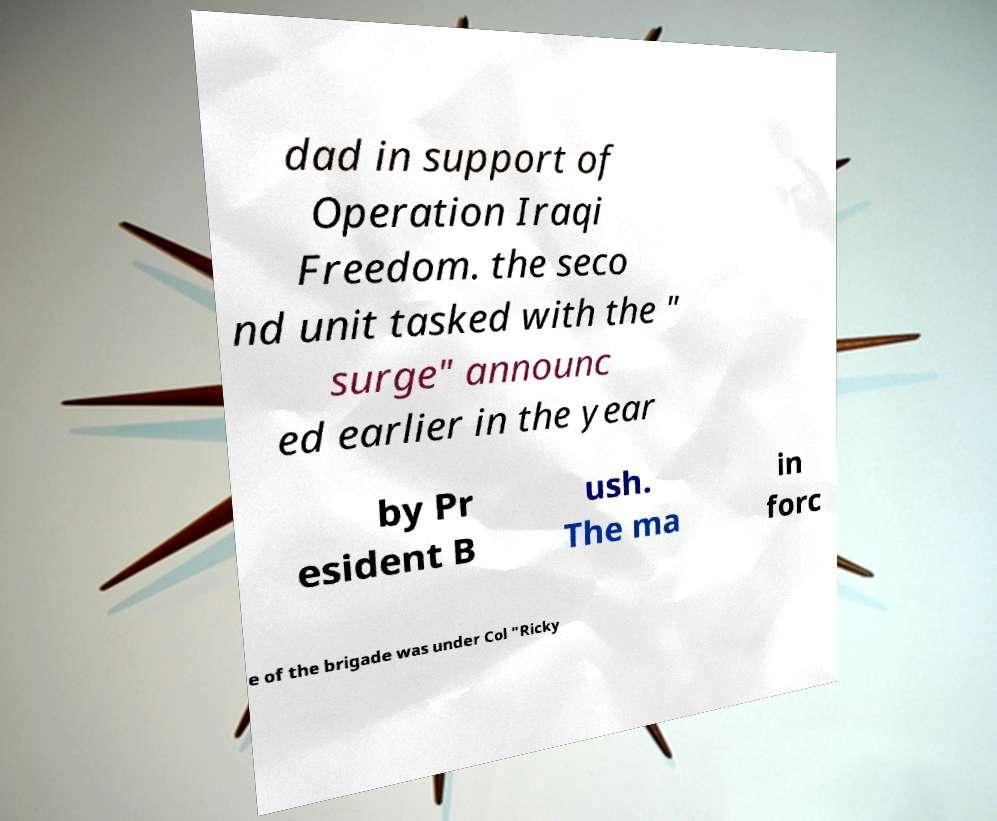What messages or text are displayed in this image? I need them in a readable, typed format. dad in support of Operation Iraqi Freedom. the seco nd unit tasked with the " surge" announc ed earlier in the year by Pr esident B ush. The ma in forc e of the brigade was under Col "Ricky 